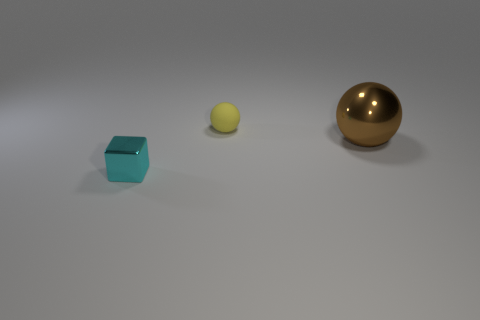How many small objects are either brown balls or yellow matte balls?
Offer a terse response. 1. Does the shiny ball have the same size as the object in front of the large ball?
Your answer should be compact. No. Is there any other thing that has the same shape as the brown metal object?
Keep it short and to the point. Yes. What number of big cyan metal objects are there?
Provide a short and direct response. 0. What number of cyan things are either shiny cubes or big balls?
Keep it short and to the point. 1. Does the small object right of the small block have the same material as the cyan thing?
Ensure brevity in your answer.  No. What number of other objects are there of the same material as the cyan cube?
Ensure brevity in your answer.  1. What is the material of the tiny yellow object?
Offer a terse response. Rubber. There is a metal object that is on the right side of the tiny shiny block; how big is it?
Provide a short and direct response. Large. There is a small thing that is on the right side of the cyan thing; how many tiny cyan things are behind it?
Keep it short and to the point. 0. 